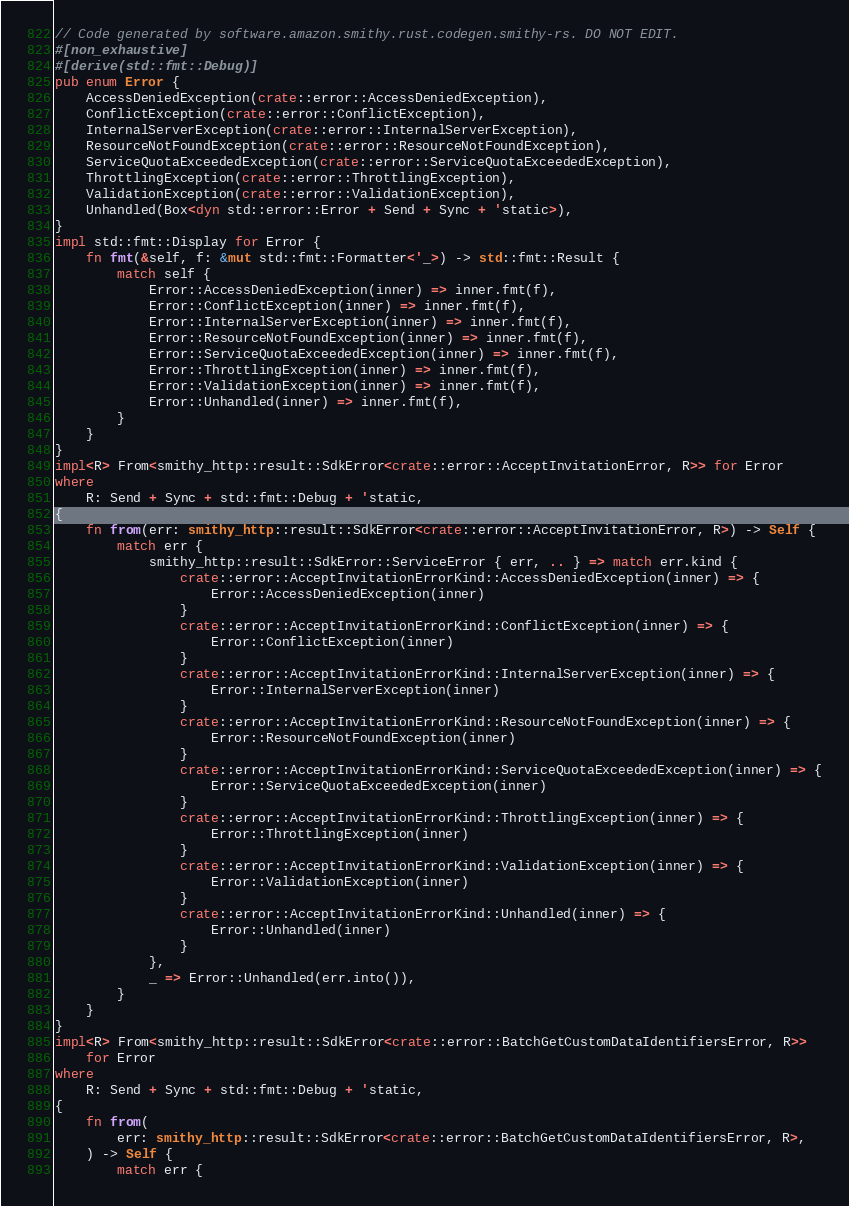Convert code to text. <code><loc_0><loc_0><loc_500><loc_500><_Rust_>// Code generated by software.amazon.smithy.rust.codegen.smithy-rs. DO NOT EDIT.
#[non_exhaustive]
#[derive(std::fmt::Debug)]
pub enum Error {
    AccessDeniedException(crate::error::AccessDeniedException),
    ConflictException(crate::error::ConflictException),
    InternalServerException(crate::error::InternalServerException),
    ResourceNotFoundException(crate::error::ResourceNotFoundException),
    ServiceQuotaExceededException(crate::error::ServiceQuotaExceededException),
    ThrottlingException(crate::error::ThrottlingException),
    ValidationException(crate::error::ValidationException),
    Unhandled(Box<dyn std::error::Error + Send + Sync + 'static>),
}
impl std::fmt::Display for Error {
    fn fmt(&self, f: &mut std::fmt::Formatter<'_>) -> std::fmt::Result {
        match self {
            Error::AccessDeniedException(inner) => inner.fmt(f),
            Error::ConflictException(inner) => inner.fmt(f),
            Error::InternalServerException(inner) => inner.fmt(f),
            Error::ResourceNotFoundException(inner) => inner.fmt(f),
            Error::ServiceQuotaExceededException(inner) => inner.fmt(f),
            Error::ThrottlingException(inner) => inner.fmt(f),
            Error::ValidationException(inner) => inner.fmt(f),
            Error::Unhandled(inner) => inner.fmt(f),
        }
    }
}
impl<R> From<smithy_http::result::SdkError<crate::error::AcceptInvitationError, R>> for Error
where
    R: Send + Sync + std::fmt::Debug + 'static,
{
    fn from(err: smithy_http::result::SdkError<crate::error::AcceptInvitationError, R>) -> Self {
        match err {
            smithy_http::result::SdkError::ServiceError { err, .. } => match err.kind {
                crate::error::AcceptInvitationErrorKind::AccessDeniedException(inner) => {
                    Error::AccessDeniedException(inner)
                }
                crate::error::AcceptInvitationErrorKind::ConflictException(inner) => {
                    Error::ConflictException(inner)
                }
                crate::error::AcceptInvitationErrorKind::InternalServerException(inner) => {
                    Error::InternalServerException(inner)
                }
                crate::error::AcceptInvitationErrorKind::ResourceNotFoundException(inner) => {
                    Error::ResourceNotFoundException(inner)
                }
                crate::error::AcceptInvitationErrorKind::ServiceQuotaExceededException(inner) => {
                    Error::ServiceQuotaExceededException(inner)
                }
                crate::error::AcceptInvitationErrorKind::ThrottlingException(inner) => {
                    Error::ThrottlingException(inner)
                }
                crate::error::AcceptInvitationErrorKind::ValidationException(inner) => {
                    Error::ValidationException(inner)
                }
                crate::error::AcceptInvitationErrorKind::Unhandled(inner) => {
                    Error::Unhandled(inner)
                }
            },
            _ => Error::Unhandled(err.into()),
        }
    }
}
impl<R> From<smithy_http::result::SdkError<crate::error::BatchGetCustomDataIdentifiersError, R>>
    for Error
where
    R: Send + Sync + std::fmt::Debug + 'static,
{
    fn from(
        err: smithy_http::result::SdkError<crate::error::BatchGetCustomDataIdentifiersError, R>,
    ) -> Self {
        match err {</code> 